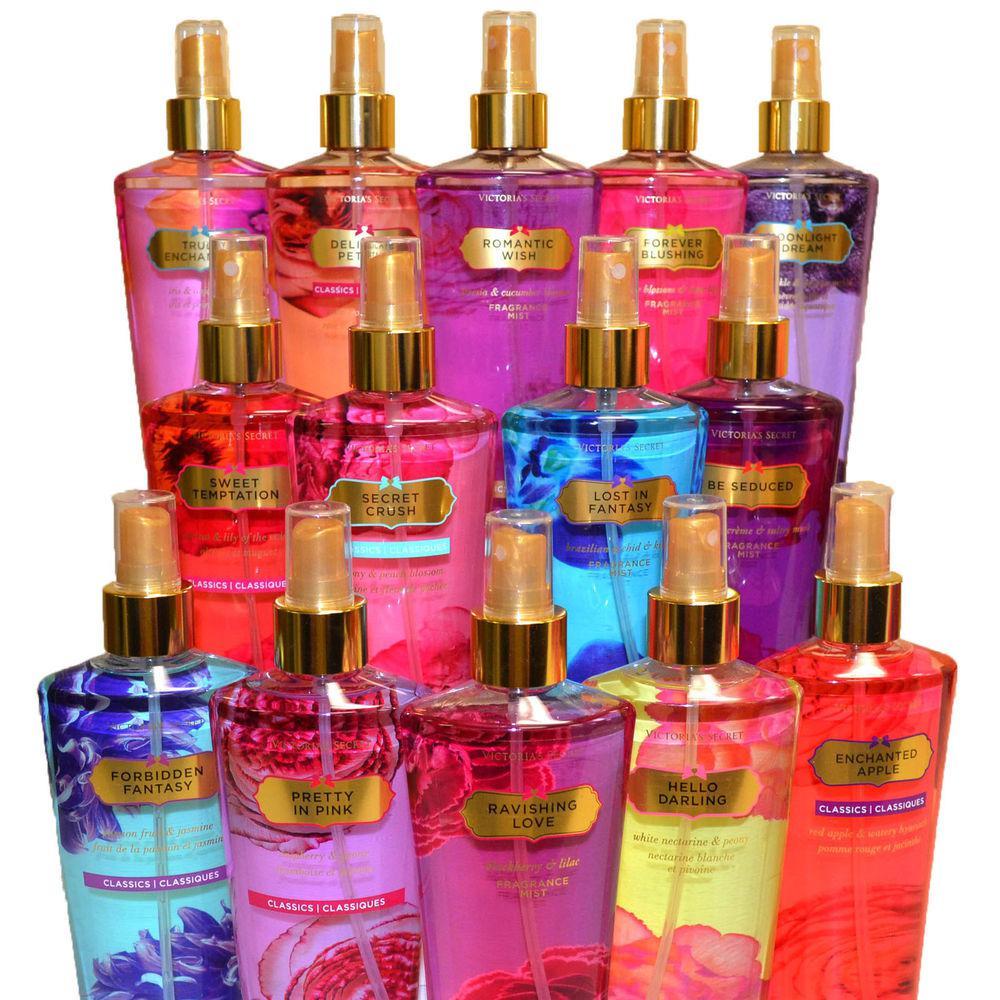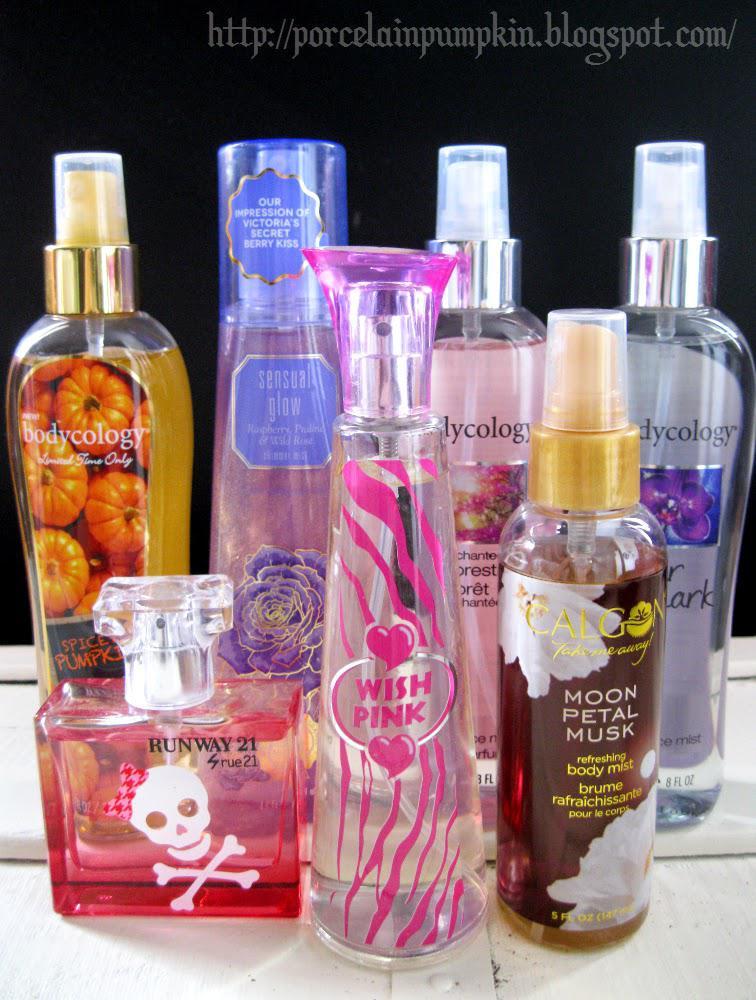The first image is the image on the left, the second image is the image on the right. Analyze the images presented: Is the assertion "An image shows exactly one fragrance standing to the right of its box." valid? Answer yes or no. No. The first image is the image on the left, the second image is the image on the right. For the images displayed, is the sentence "There is exactly one perfume bottle in the right image." factually correct? Answer yes or no. No. 